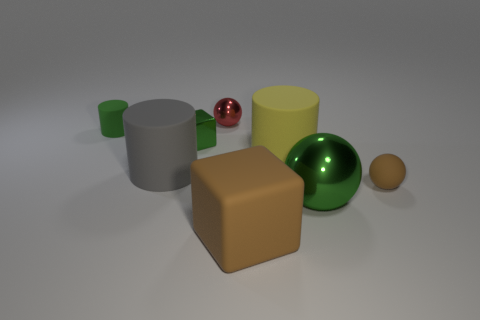Subtract all tiny green cylinders. How many cylinders are left? 2 Add 1 yellow matte objects. How many objects exist? 9 Subtract all green cubes. How many cubes are left? 1 Subtract all balls. How many objects are left? 5 Subtract 3 spheres. How many spheres are left? 0 Subtract all purple cubes. Subtract all gray cylinders. How many cubes are left? 2 Subtract all balls. Subtract all red metal objects. How many objects are left? 4 Add 1 small matte spheres. How many small matte spheres are left? 2 Add 2 small gray objects. How many small gray objects exist? 2 Subtract 0 purple cubes. How many objects are left? 8 